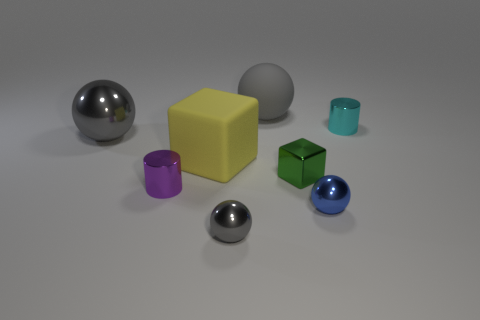How many gray spheres must be subtracted to get 1 gray spheres? 2 Subtract all gray spheres. How many spheres are left? 1 Add 2 green things. How many objects exist? 10 Subtract 1 cubes. How many cubes are left? 1 Subtract all blue spheres. How many spheres are left? 3 Subtract all cylinders. How many objects are left? 6 Subtract all green spheres. How many purple cylinders are left? 1 Add 6 green things. How many green things are left? 7 Add 5 tiny brown metallic cylinders. How many tiny brown metallic cylinders exist? 5 Subtract 0 red cubes. How many objects are left? 8 